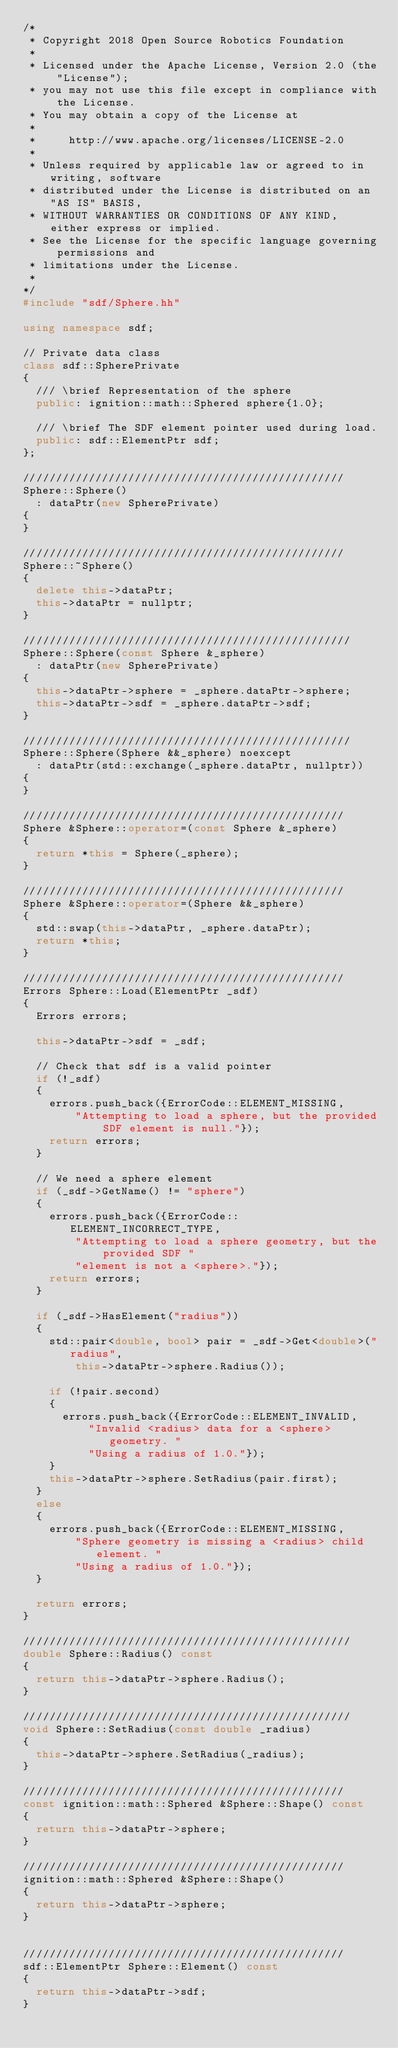<code> <loc_0><loc_0><loc_500><loc_500><_C++_>/*
 * Copyright 2018 Open Source Robotics Foundation
 *
 * Licensed under the Apache License, Version 2.0 (the "License");
 * you may not use this file except in compliance with the License.
 * You may obtain a copy of the License at
 *
 *     http://www.apache.org/licenses/LICENSE-2.0
 *
 * Unless required by applicable law or agreed to in writing, software
 * distributed under the License is distributed on an "AS IS" BASIS,
 * WITHOUT WARRANTIES OR CONDITIONS OF ANY KIND, either express or implied.
 * See the License for the specific language governing permissions and
 * limitations under the License.
 *
*/
#include "sdf/Sphere.hh"

using namespace sdf;

// Private data class
class sdf::SpherePrivate
{
  /// \brief Representation of the sphere
  public: ignition::math::Sphered sphere{1.0};

  /// \brief The SDF element pointer used during load.
  public: sdf::ElementPtr sdf;
};

/////////////////////////////////////////////////
Sphere::Sphere()
  : dataPtr(new SpherePrivate)
{
}

/////////////////////////////////////////////////
Sphere::~Sphere()
{
  delete this->dataPtr;
  this->dataPtr = nullptr;
}

//////////////////////////////////////////////////
Sphere::Sphere(const Sphere &_sphere)
  : dataPtr(new SpherePrivate)
{
  this->dataPtr->sphere = _sphere.dataPtr->sphere;
  this->dataPtr->sdf = _sphere.dataPtr->sdf;
}

//////////////////////////////////////////////////
Sphere::Sphere(Sphere &&_sphere) noexcept
  : dataPtr(std::exchange(_sphere.dataPtr, nullptr))
{
}

/////////////////////////////////////////////////
Sphere &Sphere::operator=(const Sphere &_sphere)
{
  return *this = Sphere(_sphere);
}

/////////////////////////////////////////////////
Sphere &Sphere::operator=(Sphere &&_sphere)
{
  std::swap(this->dataPtr, _sphere.dataPtr);
  return *this;
}

/////////////////////////////////////////////////
Errors Sphere::Load(ElementPtr _sdf)
{
  Errors errors;

  this->dataPtr->sdf = _sdf;

  // Check that sdf is a valid pointer
  if (!_sdf)
  {
    errors.push_back({ErrorCode::ELEMENT_MISSING,
        "Attempting to load a sphere, but the provided SDF element is null."});
    return errors;
  }

  // We need a sphere element
  if (_sdf->GetName() != "sphere")
  {
    errors.push_back({ErrorCode::ELEMENT_INCORRECT_TYPE,
        "Attempting to load a sphere geometry, but the provided SDF "
        "element is not a <sphere>."});
    return errors;
  }

  if (_sdf->HasElement("radius"))
  {
    std::pair<double, bool> pair = _sdf->Get<double>("radius",
        this->dataPtr->sphere.Radius());

    if (!pair.second)
    {
      errors.push_back({ErrorCode::ELEMENT_INVALID,
          "Invalid <radius> data for a <sphere> geometry. "
          "Using a radius of 1.0."});
    }
    this->dataPtr->sphere.SetRadius(pair.first);
  }
  else
  {
    errors.push_back({ErrorCode::ELEMENT_MISSING,
        "Sphere geometry is missing a <radius> child element. "
        "Using a radius of 1.0."});
  }

  return errors;
}

//////////////////////////////////////////////////
double Sphere::Radius() const
{
  return this->dataPtr->sphere.Radius();
}

//////////////////////////////////////////////////
void Sphere::SetRadius(const double _radius)
{
  this->dataPtr->sphere.SetRadius(_radius);
}

/////////////////////////////////////////////////
const ignition::math::Sphered &Sphere::Shape() const
{
  return this->dataPtr->sphere;
}

/////////////////////////////////////////////////
ignition::math::Sphered &Sphere::Shape()
{
  return this->dataPtr->sphere;
}


/////////////////////////////////////////////////
sdf::ElementPtr Sphere::Element() const
{
  return this->dataPtr->sdf;
}
</code> 